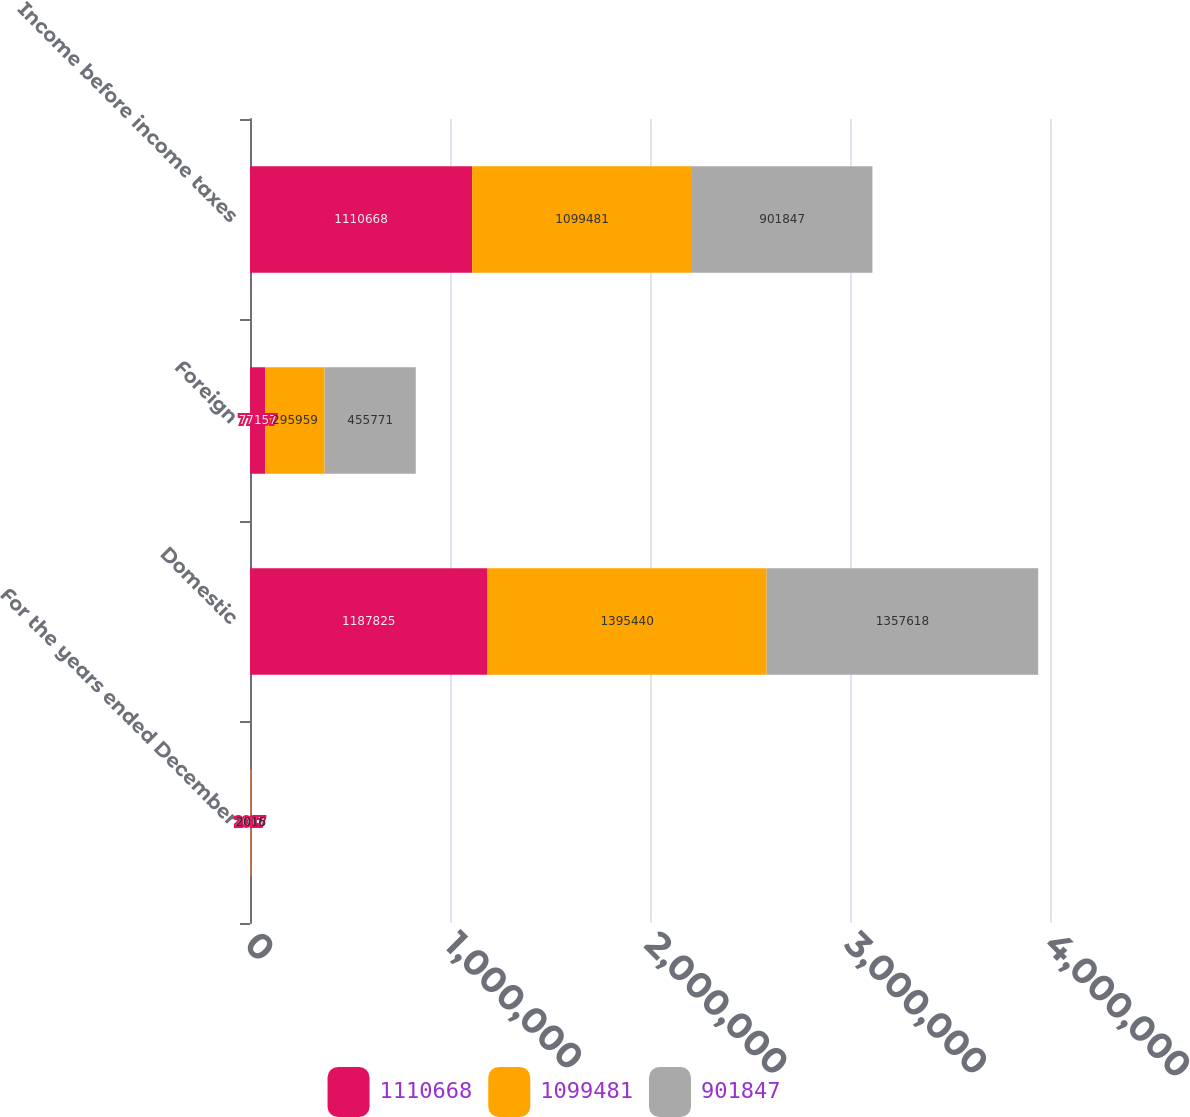Convert chart to OTSL. <chart><loc_0><loc_0><loc_500><loc_500><stacked_bar_chart><ecel><fcel>For the years ended December<fcel>Domestic<fcel>Foreign<fcel>Income before income taxes<nl><fcel>1.11067e+06<fcel>2017<fcel>1.18782e+06<fcel>77157<fcel>1.11067e+06<nl><fcel>1.09948e+06<fcel>2016<fcel>1.39544e+06<fcel>295959<fcel>1.09948e+06<nl><fcel>901847<fcel>2015<fcel>1.35762e+06<fcel>455771<fcel>901847<nl></chart> 